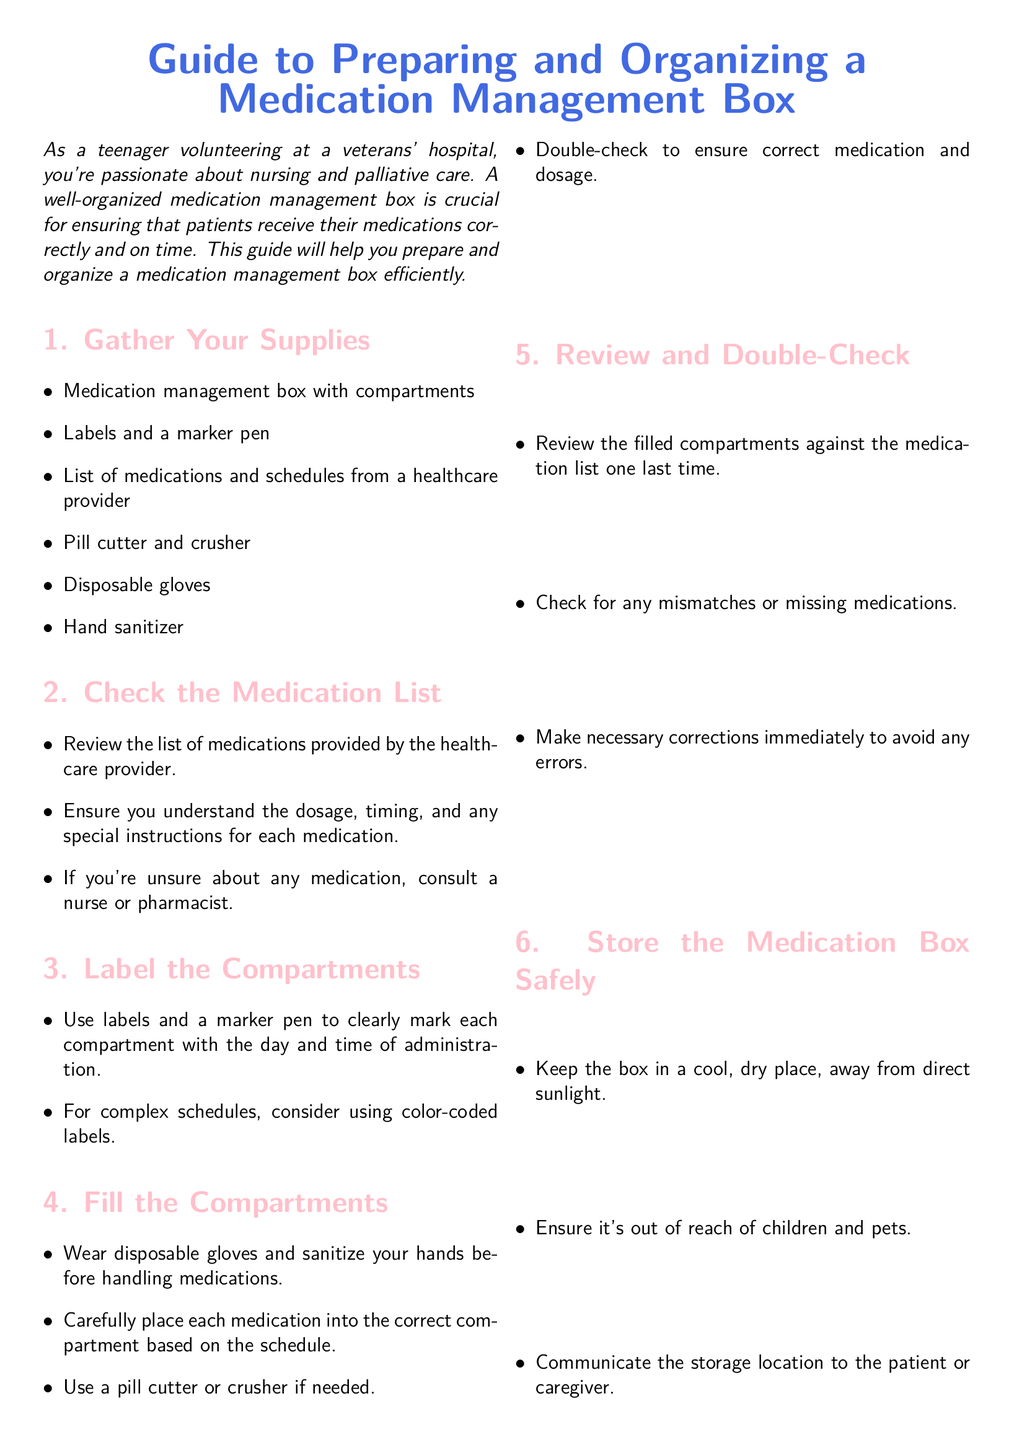What supplies are needed? The supplies required for preparing the medication management box are listed under the "Gather Your Supplies" section of the document.
Answer: Medication management box with compartments, labels and a marker pen, list of medications and schedules from a healthcare provider, pill cutter and crusher, disposable gloves, hand sanitizer What should you do if unsure about a medication? The document states that if there's uncertainty about any medication, one should consult a nurse or pharmacist.
Answer: Consult a nurse or pharmacist What should compartments be labeled with? The document specifies that each compartment should be marked with the day and time of administration.
Answer: Day and time of administration What is the last step in preparing the medication box? The last step is to review the filled compartments against the medication list one last time for mismatches or missing medications.
Answer: Review and double-check Where should the medication box be stored? The document indicates that the medication box should be kept in a cool, dry place, away from direct sunlight.
Answer: Cool, dry place, away from direct sunlight 